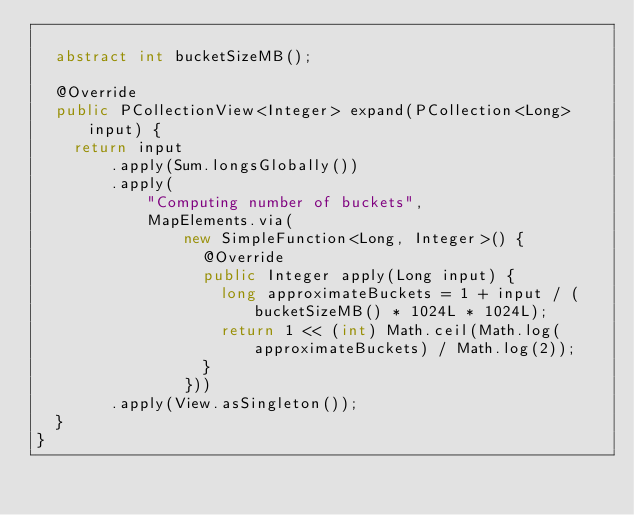<code> <loc_0><loc_0><loc_500><loc_500><_Java_>
  abstract int bucketSizeMB();

  @Override
  public PCollectionView<Integer> expand(PCollection<Long> input) {
    return input
        .apply(Sum.longsGlobally())
        .apply(
            "Computing number of buckets",
            MapElements.via(
                new SimpleFunction<Long, Integer>() {
                  @Override
                  public Integer apply(Long input) {
                    long approximateBuckets = 1 + input / (bucketSizeMB() * 1024L * 1024L);
                    return 1 << (int) Math.ceil(Math.log(approximateBuckets) / Math.log(2));
                  }
                }))
        .apply(View.asSingleton());
  }
}
</code> 